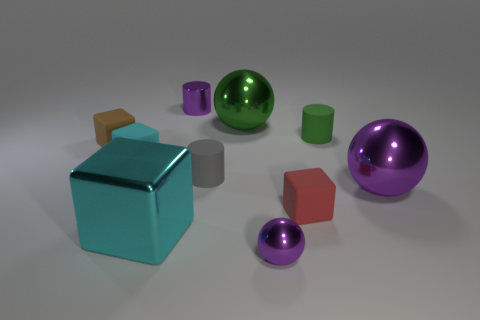Subtract all spheres. How many objects are left? 7 Subtract 0 cyan balls. How many objects are left? 10 Subtract all purple spheres. Subtract all yellow metal blocks. How many objects are left? 8 Add 6 large purple spheres. How many large purple spheres are left? 7 Add 8 big cyan blocks. How many big cyan blocks exist? 9 